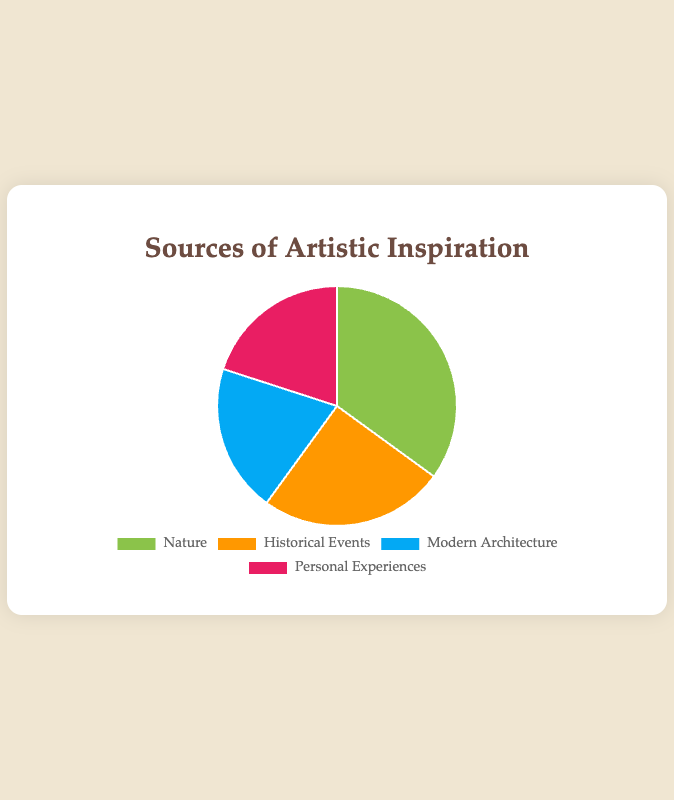What are the four sources of artistic inspiration shown in the pie chart? The pie chart includes labels for each segment, showing "Nature," "Historical Events," "Modern Architecture," and "Personal Experiences" as the sources of artistic inspiration.
Answer: Nature, Historical Events, Modern Architecture, Personal Experiences Which source of artistic inspiration has the highest percentage? The chart shows that the largest segment, colored green, represents "Nature" with 35%.
Answer: Nature What is the combined percentage for "Modern Architecture" and "Personal Experiences"? Both "Modern Architecture" and "Personal Experiences" have a segment size of 20% each. Summing them gives 20% + 20% = 40%.
Answer: 40% How much greater is the percentage of people inspired by Nature compared to Historical Events? The percentage for Nature is 35%, and for Historical Events, it is 25%. The difference is 35% - 25% = 10%.
Answer: 10% Which two categories have the same percentage of artistic inspiration? From the chart, "Modern Architecture" and "Personal Experiences" each have a percentage value of 20%.
Answer: Modern Architecture and Personal Experiences Which color represents Historical Events in the pie chart? The color associated with "Historical Events" can be seen in the segment, which is orange.
Answer: Orange What is the average percentage of all the sources of artistic inspiration represented? Summing all the percentages (35 + 25 + 20 + 20) gives 100. Dividing by the number of sources (4) yields 100 / 4 = 25%.
Answer: 25% If you combine the percentage of Historical Events and Personal Experiences, how much less is it compared to Nature? Historical Events have 25% and Personal Experiences have 20%. Combined, 25% + 20% = 45%. Nature is 35%, so the difference is 45% - 35% = 10%.
Answer: 10% Which source of inspiration has a segment colored blue? The chart shows that the blue segment represents "Modern Architecture."
Answer: Modern Architecture 